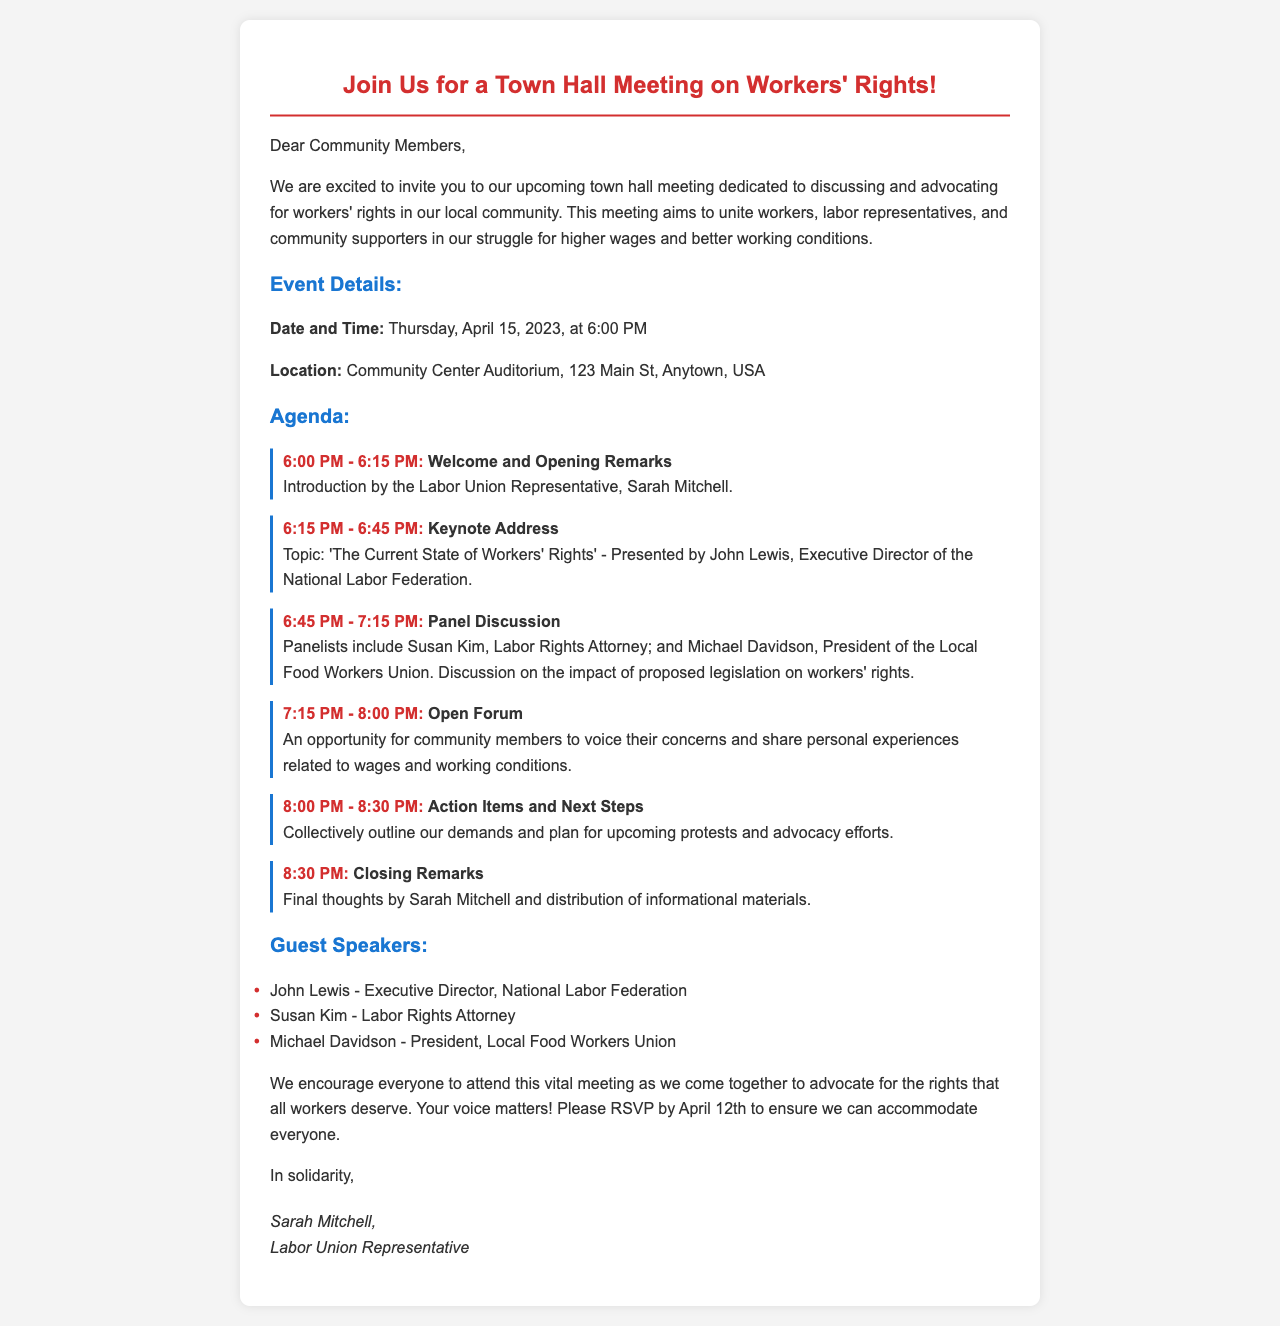What is the date of the town hall meeting? The date of the meeting is explicitly mentioned in the document as Thursday, April 15, 2023.
Answer: April 15, 2023 Who will give the keynote address? The document states that the keynote address will be presented by John Lewis, confirming his role as the speaker.
Answer: John Lewis What time does the Open Forum start? According to the agenda, the Open Forum is scheduled to start at 7:15 PM.
Answer: 7:15 PM How many guest speakers are listed? The document lists three guest speakers, which can be counted directly from the information provided.
Answer: Three What will happen during the Action Items and Next Steps segment? The agenda outlines that this segment will involve collectively outlining demands and planning for upcoming protests and advocacy efforts.
Answer: Outline demands and plan protests Who is the Labor Union Representative? The document explicitly identifies Sarah Mitchell as the Labor Union Representative at the meeting.
Answer: Sarah Mitchell What is the location of the meeting? The location is detailed as the Community Center Auditorium, 123 Main St, Anytown, USA, which is a specific address provided in the document.
Answer: Community Center Auditorium, 123 Main St, Anytown, USA What is the deadline to RSVP? The document specifies that RSVPs must be submitted by April 12th, giving a clear deadline for attendees.
Answer: April 12th What topic will John Lewis discuss in his keynote? The document mentions that John Lewis will talk about 'The Current State of Workers' Rights', indicating the subject matter of his speech.
Answer: The Current State of Workers' Rights 